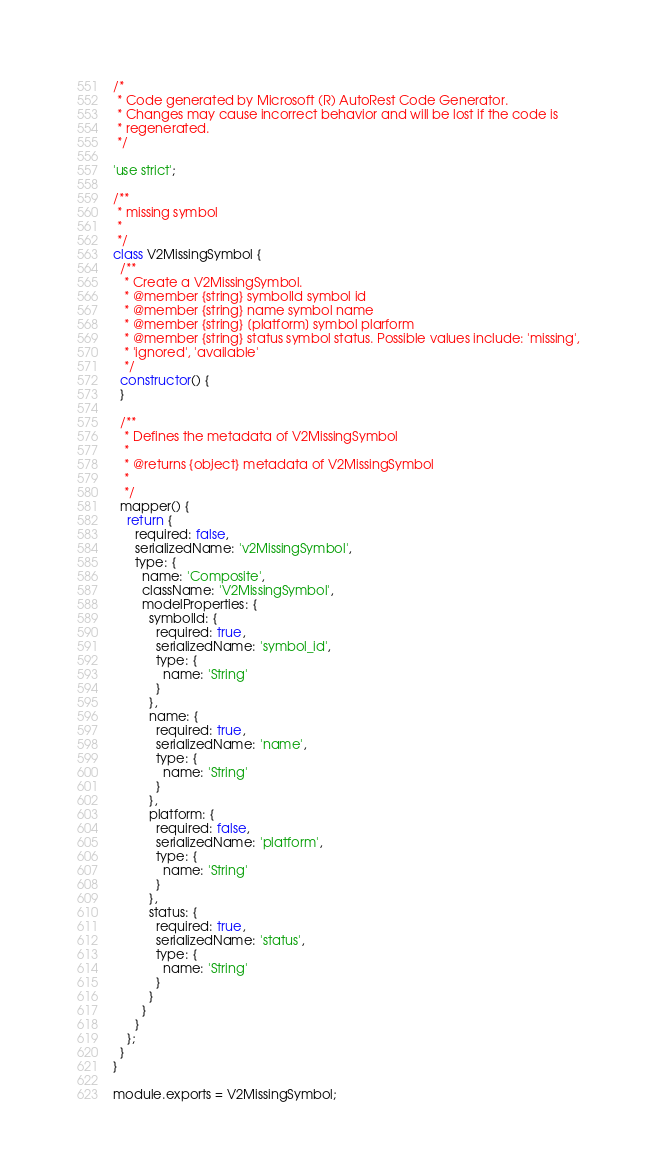<code> <loc_0><loc_0><loc_500><loc_500><_JavaScript_>/*
 * Code generated by Microsoft (R) AutoRest Code Generator.
 * Changes may cause incorrect behavior and will be lost if the code is
 * regenerated.
 */

'use strict';

/**
 * missing symbol
 *
 */
class V2MissingSymbol {
  /**
   * Create a V2MissingSymbol.
   * @member {string} symbolId symbol id
   * @member {string} name symbol name
   * @member {string} [platform] symbol plarform
   * @member {string} status symbol status. Possible values include: 'missing',
   * 'ignored', 'available'
   */
  constructor() {
  }

  /**
   * Defines the metadata of V2MissingSymbol
   *
   * @returns {object} metadata of V2MissingSymbol
   *
   */
  mapper() {
    return {
      required: false,
      serializedName: 'v2MissingSymbol',
      type: {
        name: 'Composite',
        className: 'V2MissingSymbol',
        modelProperties: {
          symbolId: {
            required: true,
            serializedName: 'symbol_id',
            type: {
              name: 'String'
            }
          },
          name: {
            required: true,
            serializedName: 'name',
            type: {
              name: 'String'
            }
          },
          platform: {
            required: false,
            serializedName: 'platform',
            type: {
              name: 'String'
            }
          },
          status: {
            required: true,
            serializedName: 'status',
            type: {
              name: 'String'
            }
          }
        }
      }
    };
  }
}

module.exports = V2MissingSymbol;
</code> 